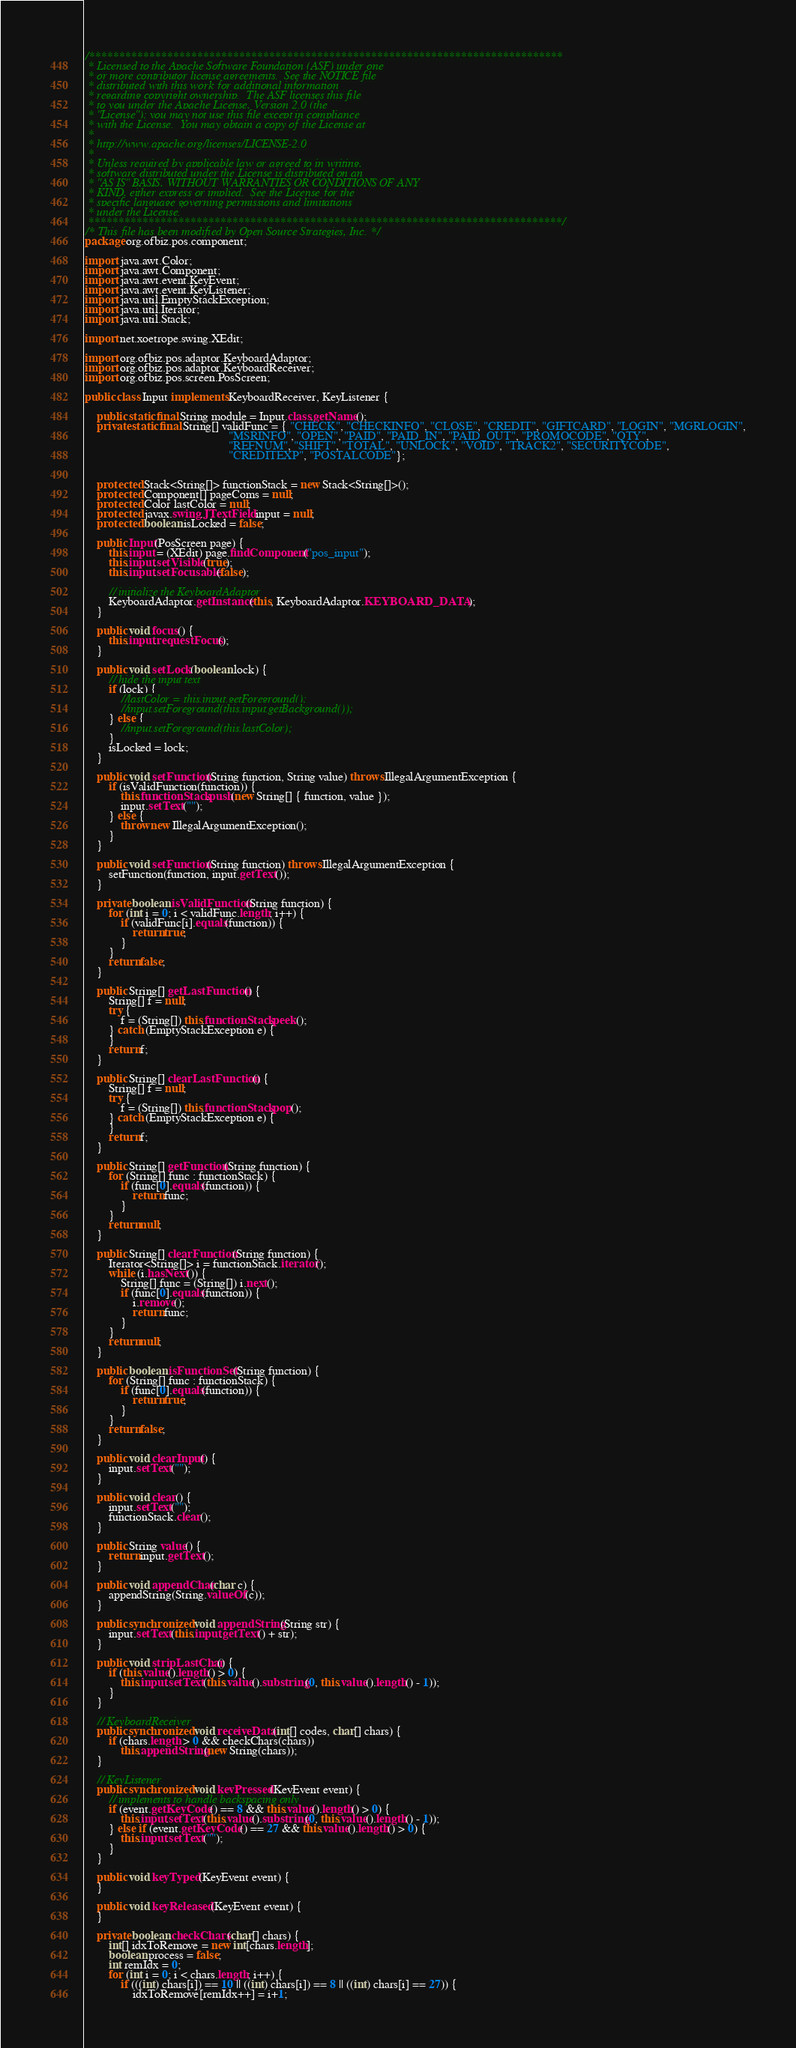Convert code to text. <code><loc_0><loc_0><loc_500><loc_500><_Java_>/*******************************************************************************
 * Licensed to the Apache Software Foundation (ASF) under one
 * or more contributor license agreements.  See the NOTICE file
 * distributed with this work for additional information
 * regarding copyright ownership.  The ASF licenses this file
 * to you under the Apache License, Version 2.0 (the
 * "License"); you may not use this file except in compliance
 * with the License.  You may obtain a copy of the License at
 *
 * http://www.apache.org/licenses/LICENSE-2.0
 *
 * Unless required by applicable law or agreed to in writing,
 * software distributed under the License is distributed on an
 * "AS IS" BASIS, WITHOUT WARRANTIES OR CONDITIONS OF ANY
 * KIND, either express or implied.  See the License for the
 * specific language governing permissions and limitations
 * under the License.
 *******************************************************************************/
/* This file has been modified by Open Source Strategies, Inc. */
package org.ofbiz.pos.component;

import java.awt.Color;
import java.awt.Component;
import java.awt.event.KeyEvent;
import java.awt.event.KeyListener;
import java.util.EmptyStackException;
import java.util.Iterator;
import java.util.Stack;

import net.xoetrope.swing.XEdit;

import org.ofbiz.pos.adaptor.KeyboardAdaptor;
import org.ofbiz.pos.adaptor.KeyboardReceiver;
import org.ofbiz.pos.screen.PosScreen;

public class Input implements KeyboardReceiver, KeyListener {

    public static final String module = Input.class.getName();
    private static final String[] validFunc = { "CHECK", "CHECKINFO", "CLOSE", "CREDIT", "GIFTCARD", "LOGIN", "MGRLOGIN",
                                                "MSRINFO", "OPEN", "PAID", "PAID_IN", "PAID_OUT", "PROMOCODE", "QTY",
                                                "REFNUM", "SHIFT", "TOTAL", "UNLOCK", "VOID", "TRACK2", "SECURITYCODE",
                                                "CREDITEXP", "POSTALCODE"};


    protected Stack<String[]> functionStack = new Stack<String[]>();
    protected Component[] pageComs = null;
    protected Color lastColor = null;
    protected javax.swing.JTextField input = null;
    protected boolean isLocked = false;

    public Input(PosScreen page) {
        this.input = (XEdit) page.findComponent("pos_input");
        this.input.setVisible(true);
        this.input.setFocusable(false);

        // initialize the KeyboardAdaptor
        KeyboardAdaptor.getInstance(this, KeyboardAdaptor.KEYBOARD_DATA);
    }

    public void focus() {
        this.input.requestFocus();
    }

    public void setLock(boolean lock) {
        // hide the input text
        if (lock) {
            //lastColor = this.input.getForeground();
            //input.setForeground(this.input.getBackground());
        } else {
            //input.setForeground(this.lastColor);
        }
        isLocked = lock;
    }

    public void setFunction(String function, String value) throws IllegalArgumentException {
        if (isValidFunction(function)) {
            this.functionStack.push(new String[] { function, value });
            input.setText("");
        } else {
            throw new IllegalArgumentException();
        }
    }

    public void setFunction(String function) throws IllegalArgumentException {
        setFunction(function, input.getText());
    }

    private boolean isValidFunction(String function) {
        for (int i = 0; i < validFunc.length; i++) {
            if (validFunc[i].equals(function)) {
                return true;
            }
        }
        return false;
    }

    public String[] getLastFunction() {
        String[] f = null;
        try {
            f = (String[]) this.functionStack.peek();
        } catch (EmptyStackException e) {
        }
        return f;
    }

    public String[] clearLastFunction() {
        String[] f = null;
        try {
            f = (String[]) this.functionStack.pop();
        } catch (EmptyStackException e) {
        }
        return f;
    }

    public String[] getFunction(String function) {
        for (String[] func : functionStack) {
            if (func[0].equals(function)) {
                return func;
            }
        }
        return null;
    }

    public String[] clearFunction(String function) {
        Iterator<String[]> i = functionStack.iterator();
        while (i.hasNext()) {
            String[] func = (String[]) i.next();
            if (func[0].equals(function)) {
                i.remove();
                return func;
            }
        }
        return null;
    }

    public boolean isFunctionSet(String function) {
        for (String[] func : functionStack) {
            if (func[0].equals(function)) {
                return true;
            }
        }
        return false;
    }

    public void clearInput() {
        input.setText("");
    }

    public void clear() {
        input.setText("");
        functionStack.clear();
    }

    public String value() {
        return input.getText();
    }

    public void appendChar(char c) {
        appendString(String.valueOf(c));
    }

    public synchronized void appendString(String str) {
        input.setText(this.input.getText() + str);
    }

    public void stripLastChar() {
        if (this.value().length() > 0) {
            this.input.setText(this.value().substring(0, this.value().length() - 1));
        }
    }

    // KeyboardReceiver
    public synchronized void receiveData(int[] codes, char[] chars) {
        if (chars.length > 0 && checkChars(chars))
            this.appendString(new String(chars));
    }

    // KeyListener
    public synchronized void keyPressed(KeyEvent event) {
        // implements to handle backspacing only
        if (event.getKeyCode() == 8 && this.value().length() > 0) {
            this.input.setText(this.value().substring(0, this.value().length() - 1));
        } else if (event.getKeyCode() == 27 && this.value().length() > 0) {
            this.input.setText("");
        }
    }

    public void keyTyped(KeyEvent event) {
    }

    public void keyReleased(KeyEvent event) {
    }

    private boolean checkChars(char[] chars) {
        int[] idxToRemove = new int[chars.length];
        boolean process = false;
        int remIdx = 0;
        for (int i = 0; i < chars.length; i++) {
            if (((int) chars[i]) == 10 || ((int) chars[i]) == 8 || ((int) chars[i] == 27)) {
                idxToRemove[remIdx++] = i+1;</code> 